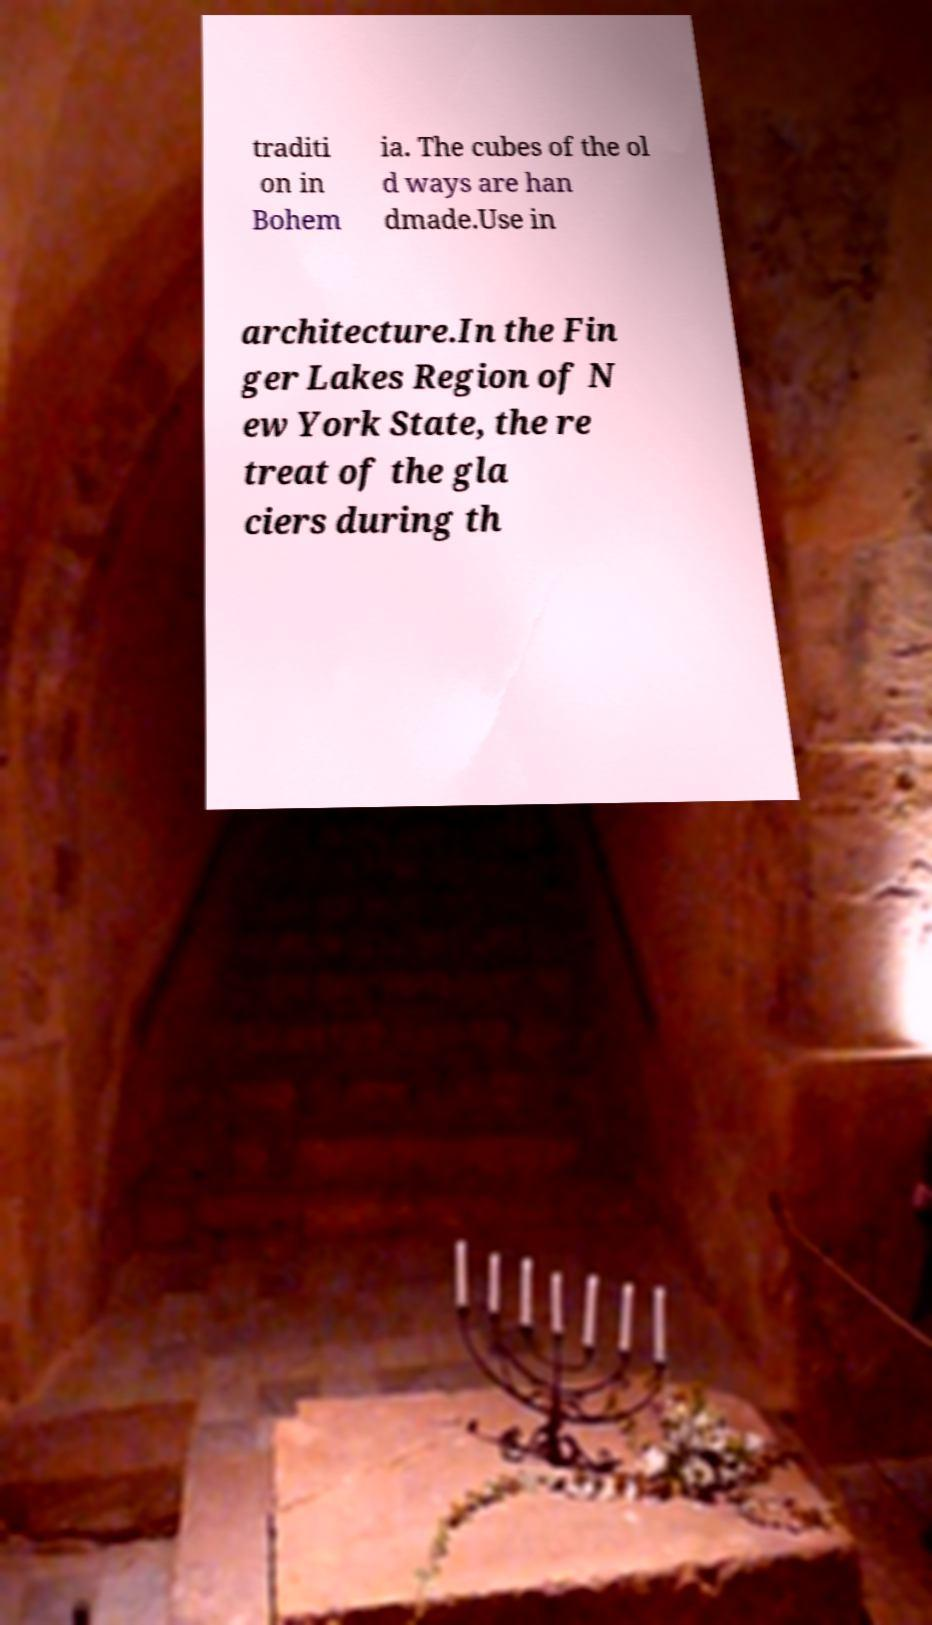What messages or text are displayed in this image? I need them in a readable, typed format. traditi on in Bohem ia. The cubes of the ol d ways are han dmade.Use in architecture.In the Fin ger Lakes Region of N ew York State, the re treat of the gla ciers during th 